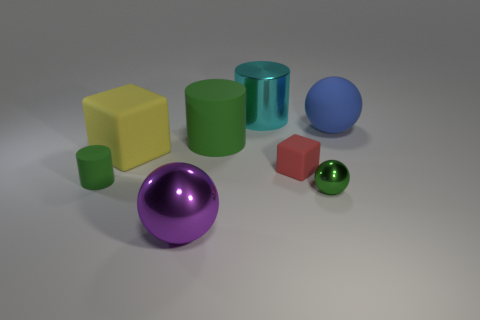Is the shape of the blue matte thing the same as the small green metallic thing?
Your answer should be very brief. Yes. There is a green object that is the same shape as the purple object; what is it made of?
Keep it short and to the point. Metal. What color is the object that is both in front of the tiny matte block and to the right of the large purple thing?
Offer a terse response. Green. What is the color of the tiny cube?
Provide a succinct answer. Red. There is a big cylinder that is the same color as the small ball; what is it made of?
Offer a very short reply. Rubber. Are there any cyan metal objects of the same shape as the big yellow rubber thing?
Offer a terse response. No. What size is the matte cylinder that is on the right side of the big yellow thing?
Provide a succinct answer. Large. What material is the purple ball that is the same size as the yellow cube?
Offer a very short reply. Metal. Are there more large brown rubber balls than big green rubber things?
Provide a short and direct response. No. What is the size of the metal sphere to the left of the green thing on the right side of the large green cylinder?
Offer a terse response. Large. 